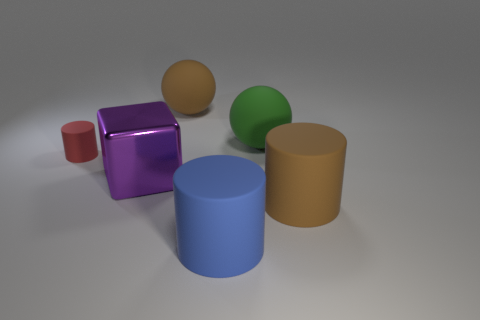Subtract all large cylinders. How many cylinders are left? 1 Add 2 blue matte objects. How many objects exist? 8 Subtract all cyan cylinders. Subtract all purple cubes. How many cylinders are left? 3 Subtract all balls. How many objects are left? 4 Add 3 purple metallic blocks. How many purple metallic blocks are left? 4 Add 4 big green things. How many big green things exist? 5 Subtract 0 yellow blocks. How many objects are left? 6 Subtract all big green rubber balls. Subtract all tiny purple rubber things. How many objects are left? 5 